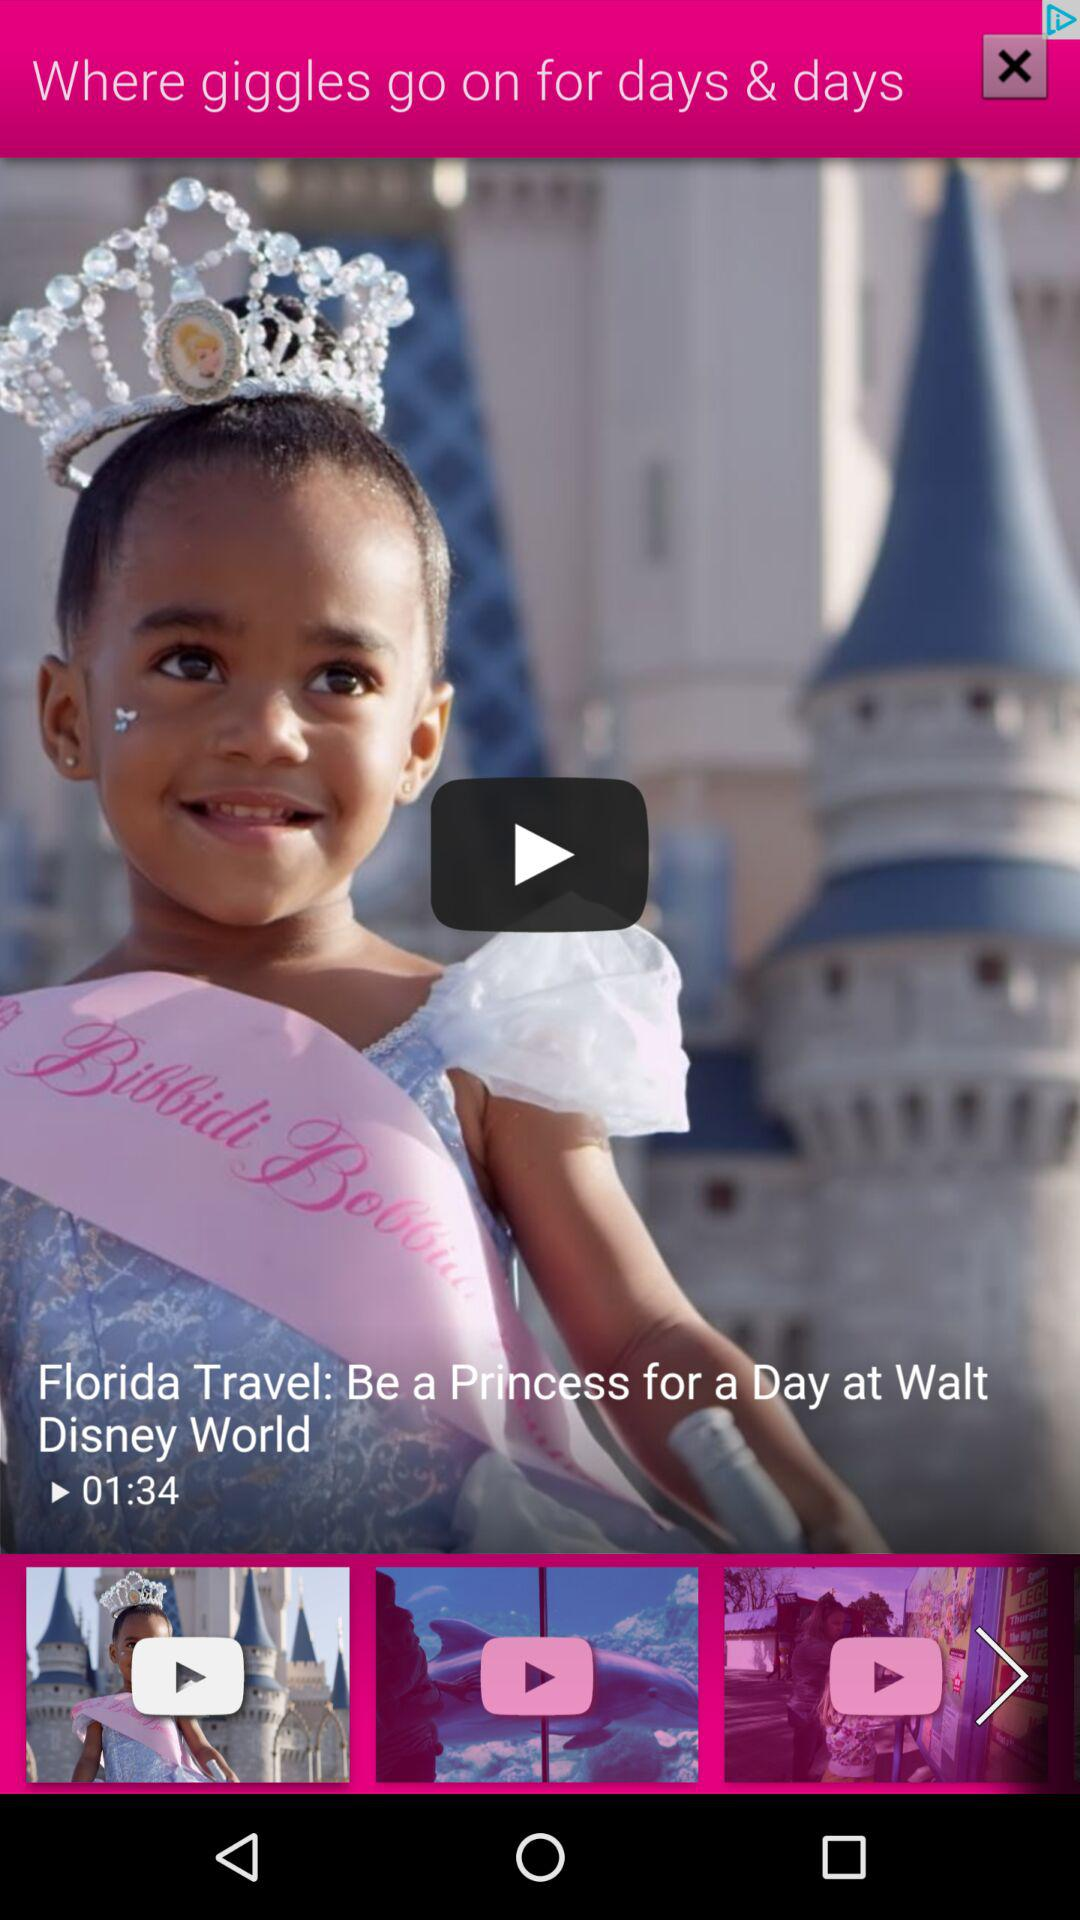What is the length of the "Florida Travel" video? The length of the "Florida Travel" video is 1 minute and 34 seconds. 